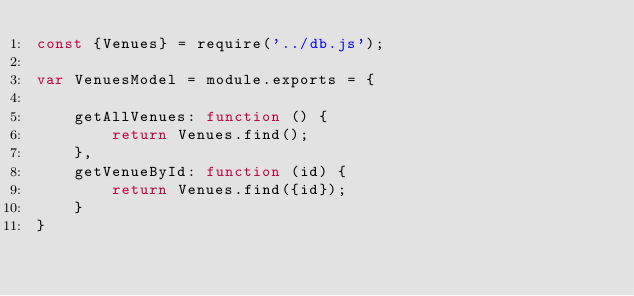Convert code to text. <code><loc_0><loc_0><loc_500><loc_500><_JavaScript_>const {Venues} = require('../db.js');

var VenuesModel = module.exports = {

    getAllVenues: function () {
        return Venues.find();
    },
    getVenueById: function (id) {
        return Venues.find({id});
    }
}</code> 